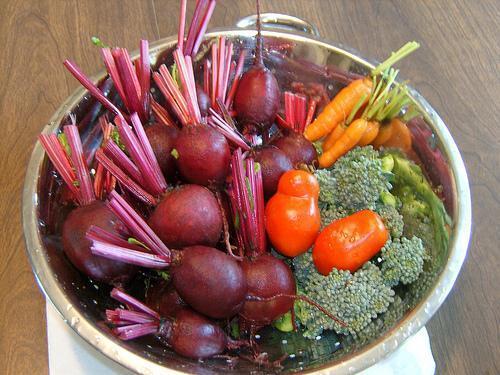How many different types of vegetables are shown?
Give a very brief answer. 4. 